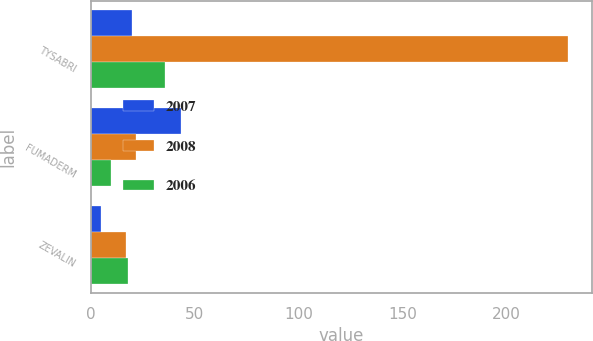Convert chart. <chart><loc_0><loc_0><loc_500><loc_500><stacked_bar_chart><ecel><fcel>TYSABRI<fcel>FUMADERM<fcel>ZEVALIN<nl><fcel>2007<fcel>19.65<fcel>43.4<fcel>4.8<nl><fcel>2008<fcel>229.9<fcel>21.5<fcel>16.9<nl><fcel>2006<fcel>35.8<fcel>9.5<fcel>17.8<nl></chart> 